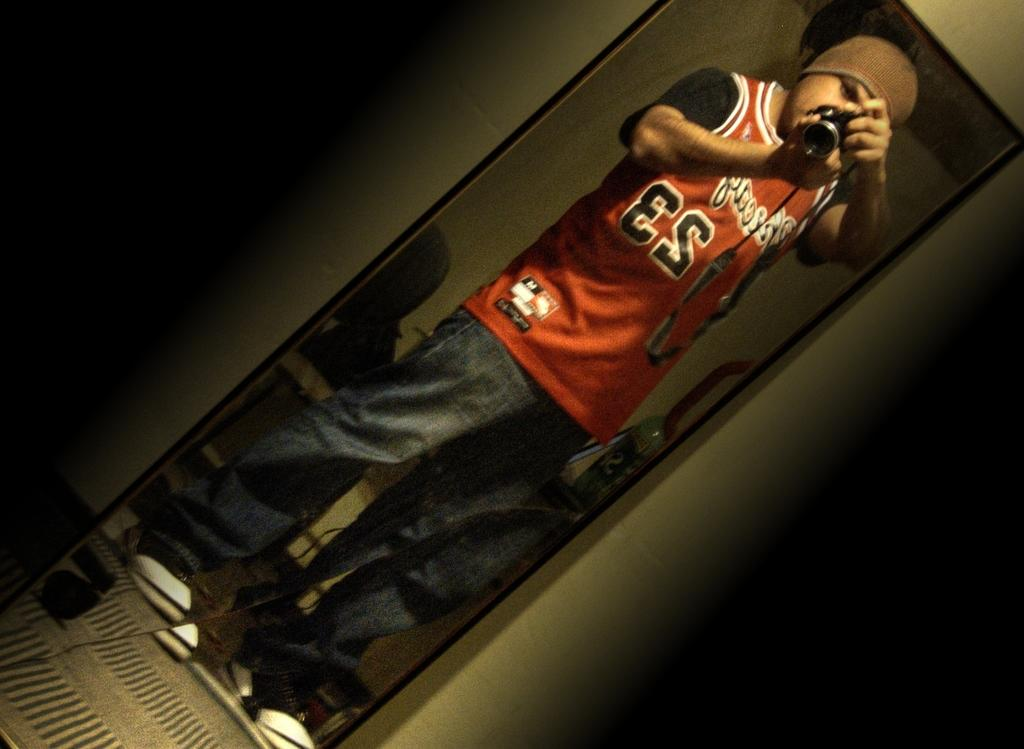<image>
Relay a brief, clear account of the picture shown. A gentleman wearing a red, white and black jersey with the number 23 is taking a photo of himself in a mirror. 